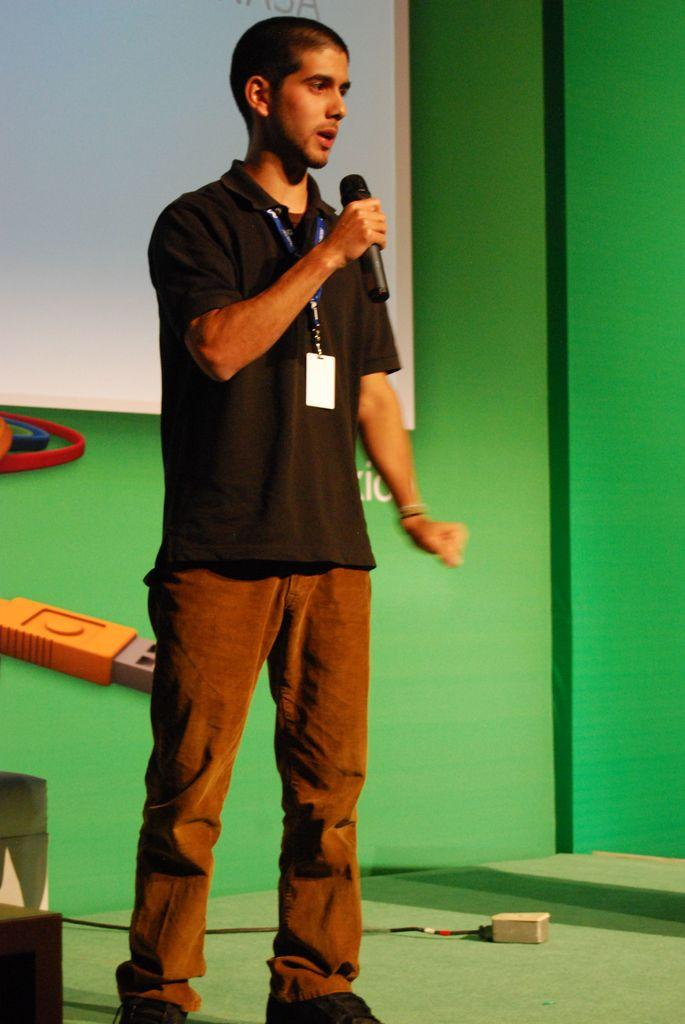What is the main subject of the image? The main subject of the image is a man. What is the man doing in the image? The man is standing and speaking into a microphone. What is the man wearing in the image? The man is wearing a black t-shirt. What can be seen in the background of the image? There is a green-colored wall in the background. What type of bread is the woman holding in the image? There is no woman present in the image, and therefore no bread can be observed. 